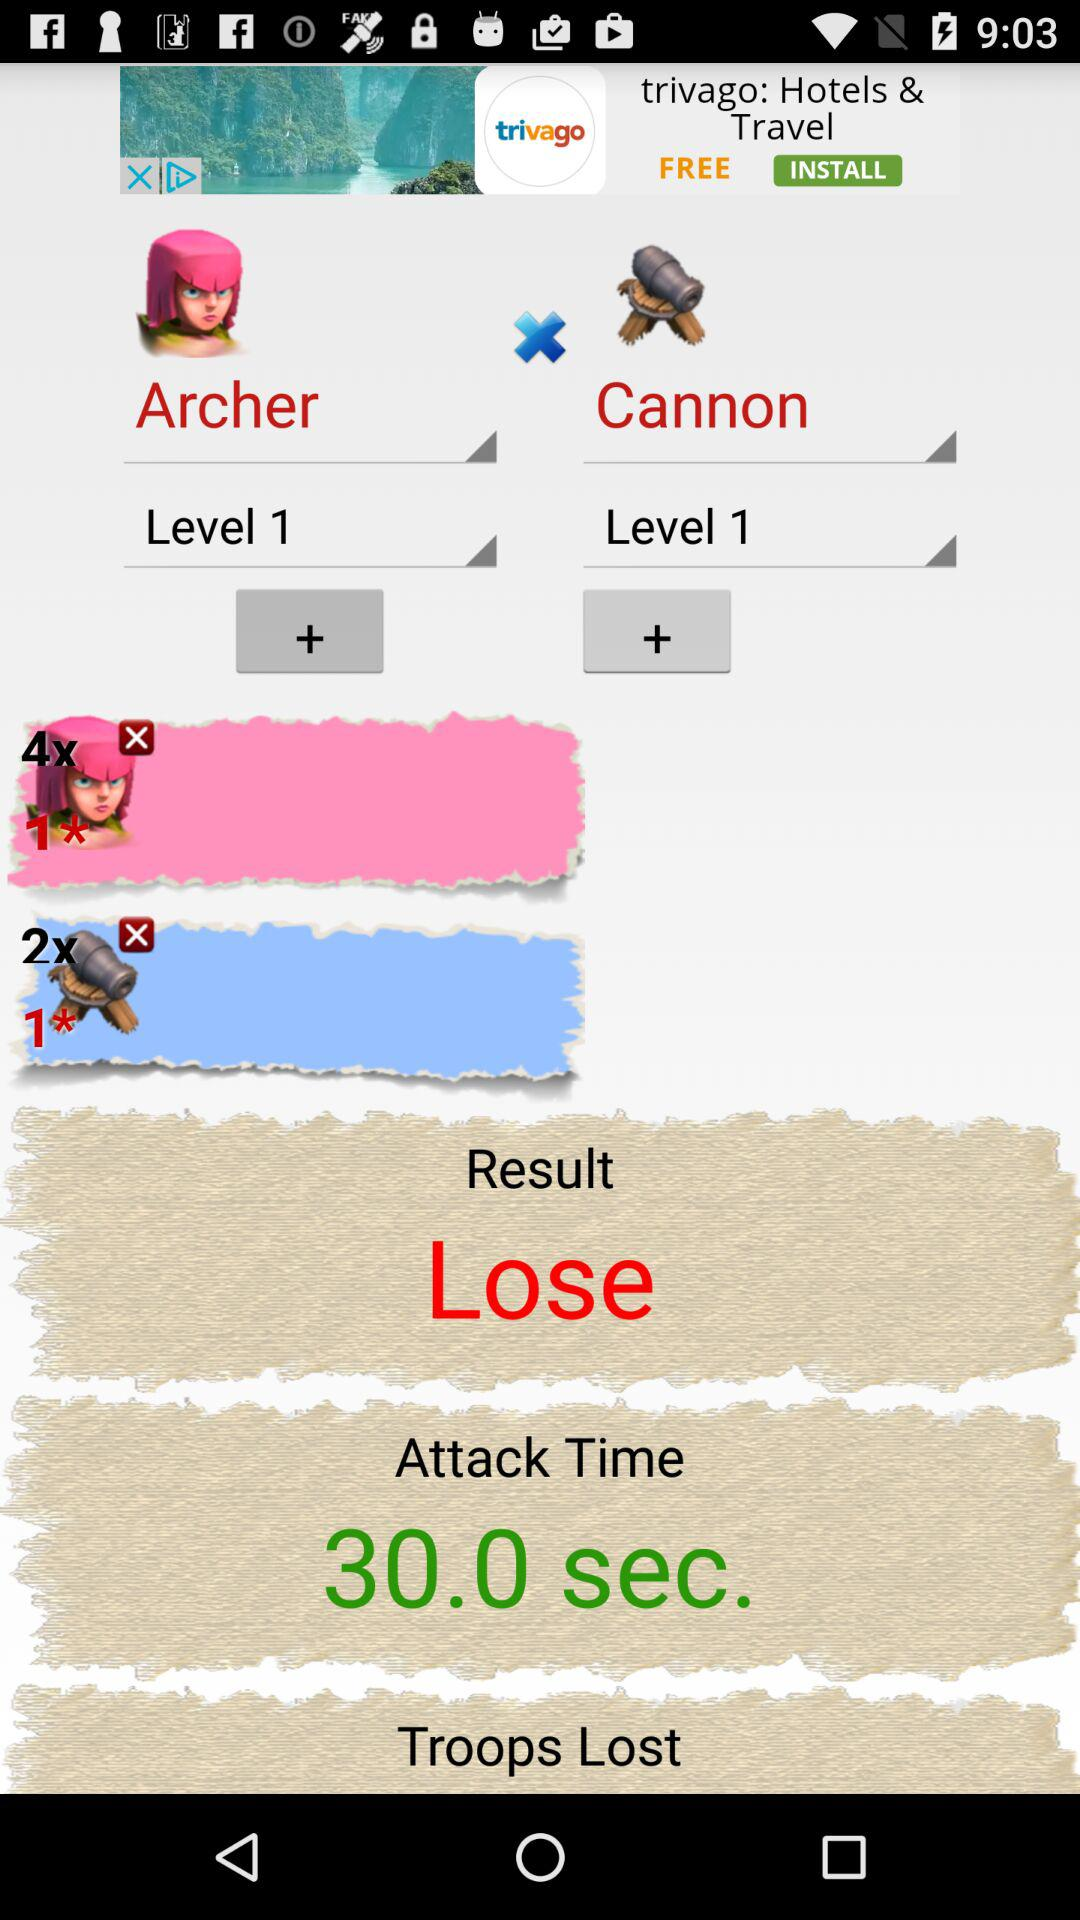What digit will be multiplied by the points of Archer? The points will be multiplied by the digit 4. 